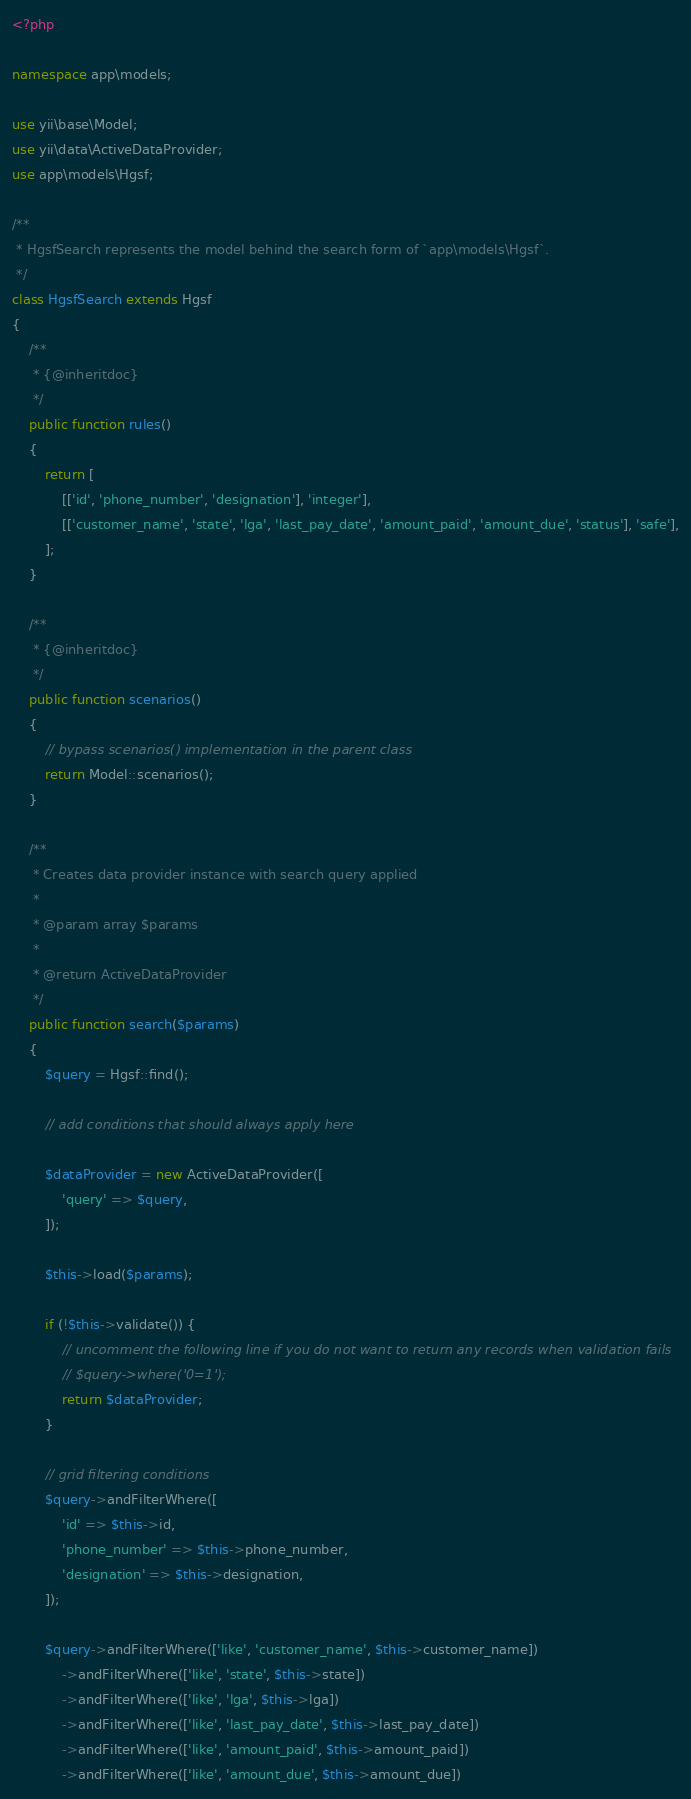Convert code to text. <code><loc_0><loc_0><loc_500><loc_500><_PHP_><?php

namespace app\models;

use yii\base\Model;
use yii\data\ActiveDataProvider;
use app\models\Hgsf;

/**
 * HgsfSearch represents the model behind the search form of `app\models\Hgsf`.
 */
class HgsfSearch extends Hgsf
{
    /**
     * {@inheritdoc}
     */
    public function rules()
    {
        return [
            [['id', 'phone_number', 'designation'], 'integer'],
            [['customer_name', 'state', 'lga', 'last_pay_date', 'amount_paid', 'amount_due', 'status'], 'safe'],
        ];
    }

    /**
     * {@inheritdoc}
     */
    public function scenarios()
    {
        // bypass scenarios() implementation in the parent class
        return Model::scenarios();
    }

    /**
     * Creates data provider instance with search query applied
     *
     * @param array $params
     *
     * @return ActiveDataProvider
     */
    public function search($params)
    {
        $query = Hgsf::find();

        // add conditions that should always apply here

        $dataProvider = new ActiveDataProvider([
            'query' => $query,
        ]);

        $this->load($params);

        if (!$this->validate()) {
            // uncomment the following line if you do not want to return any records when validation fails
            // $query->where('0=1');
            return $dataProvider;
        }

        // grid filtering conditions
        $query->andFilterWhere([
            'id' => $this->id,
            'phone_number' => $this->phone_number,
            'designation' => $this->designation,
        ]);

        $query->andFilterWhere(['like', 'customer_name', $this->customer_name])
            ->andFilterWhere(['like', 'state', $this->state])
            ->andFilterWhere(['like', 'lga', $this->lga])
            ->andFilterWhere(['like', 'last_pay_date', $this->last_pay_date])
            ->andFilterWhere(['like', 'amount_paid', $this->amount_paid])
            ->andFilterWhere(['like', 'amount_due', $this->amount_due])</code> 